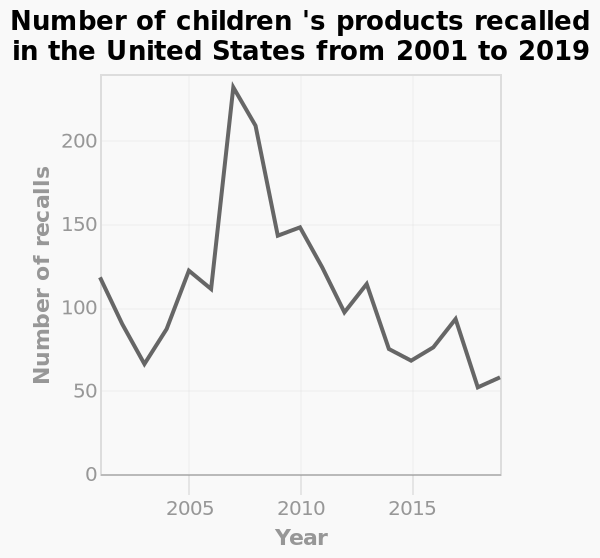<image>
What was the lowest number of recalls recorded? The lowest number of recalls recorded was 50. What type of chart is used to represent the data? A line chart is used to represent the number of children's products recalled. 